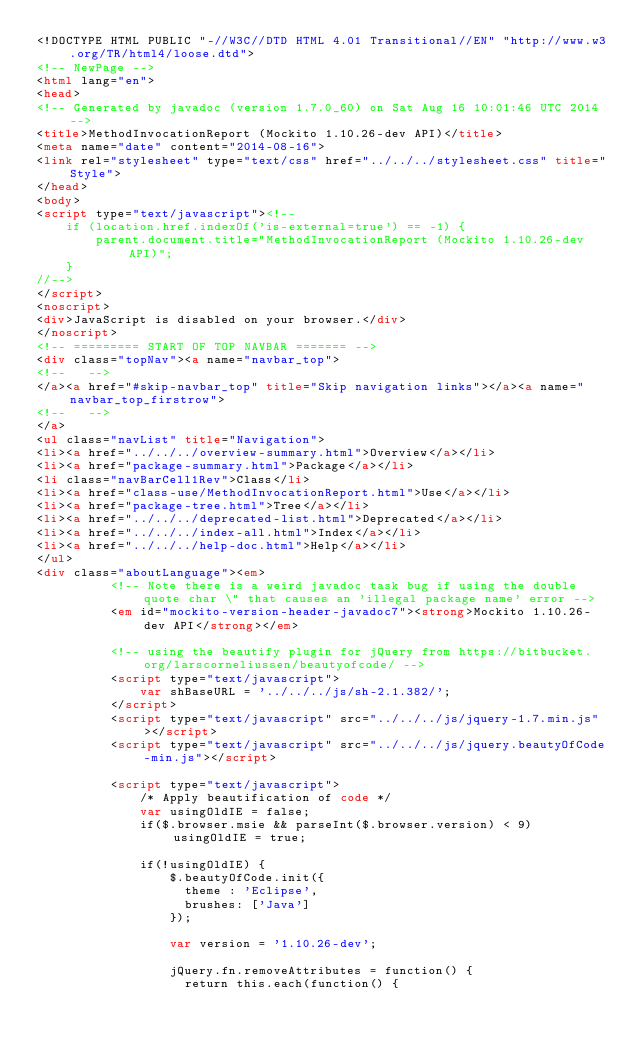Convert code to text. <code><loc_0><loc_0><loc_500><loc_500><_HTML_><!DOCTYPE HTML PUBLIC "-//W3C//DTD HTML 4.01 Transitional//EN" "http://www.w3.org/TR/html4/loose.dtd">
<!-- NewPage -->
<html lang="en">
<head>
<!-- Generated by javadoc (version 1.7.0_60) on Sat Aug 16 10:01:46 UTC 2014 -->
<title>MethodInvocationReport (Mockito 1.10.26-dev API)</title>
<meta name="date" content="2014-08-16">
<link rel="stylesheet" type="text/css" href="../../../stylesheet.css" title="Style">
</head>
<body>
<script type="text/javascript"><!--
    if (location.href.indexOf('is-external=true') == -1) {
        parent.document.title="MethodInvocationReport (Mockito 1.10.26-dev API)";
    }
//-->
</script>
<noscript>
<div>JavaScript is disabled on your browser.</div>
</noscript>
<!-- ========= START OF TOP NAVBAR ======= -->
<div class="topNav"><a name="navbar_top">
<!--   -->
</a><a href="#skip-navbar_top" title="Skip navigation links"></a><a name="navbar_top_firstrow">
<!--   -->
</a>
<ul class="navList" title="Navigation">
<li><a href="../../../overview-summary.html">Overview</a></li>
<li><a href="package-summary.html">Package</a></li>
<li class="navBarCell1Rev">Class</li>
<li><a href="class-use/MethodInvocationReport.html">Use</a></li>
<li><a href="package-tree.html">Tree</a></li>
<li><a href="../../../deprecated-list.html">Deprecated</a></li>
<li><a href="../../../index-all.html">Index</a></li>
<li><a href="../../../help-doc.html">Help</a></li>
</ul>
<div class="aboutLanguage"><em>
          <!-- Note there is a weird javadoc task bug if using the double quote char \" that causes an 'illegal package name' error -->
          <em id="mockito-version-header-javadoc7"><strong>Mockito 1.10.26-dev API</strong></em>

          <!-- using the beautify plugin for jQuery from https://bitbucket.org/larscorneliussen/beautyofcode/ -->
          <script type="text/javascript">
              var shBaseURL = '../../../js/sh-2.1.382/';
          </script>
          <script type="text/javascript" src="../../../js/jquery-1.7.min.js"></script>
          <script type="text/javascript" src="../../../js/jquery.beautyOfCode-min.js"></script>

          <script type="text/javascript">
              /* Apply beautification of code */
              var usingOldIE = false;
              if($.browser.msie && parseInt($.browser.version) < 9) usingOldIE = true;

              if(!usingOldIE) {
                  $.beautyOfCode.init({
                    theme : 'Eclipse',
                    brushes: ['Java']
                  });

                  var version = '1.10.26-dev';

                  jQuery.fn.removeAttributes = function() {
                    return this.each(function() {</code> 